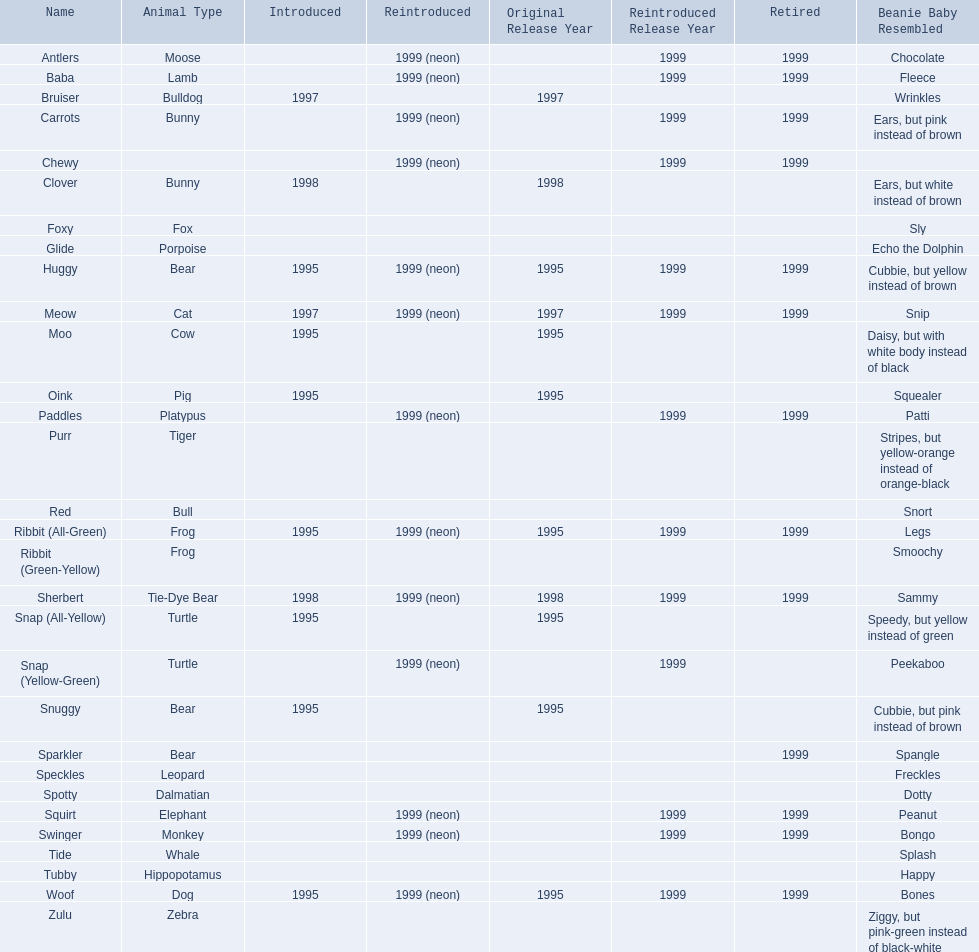What are the types of pillow pal animals? Antlers, Moose, Lamb, Bulldog, Bunny, , Bunny, Fox, Porpoise, Bear, Cat, Cow, Pig, Platypus, Tiger, Bull, Frog, Frog, Tie-Dye Bear, Turtle, Turtle, Bear, Bear, Leopard, Dalmatian, Elephant, Monkey, Whale, Hippopotamus, Dog, Zebra. Of those, which is a dalmatian? Dalmatian. What is the name of the dalmatian? Spotty. 